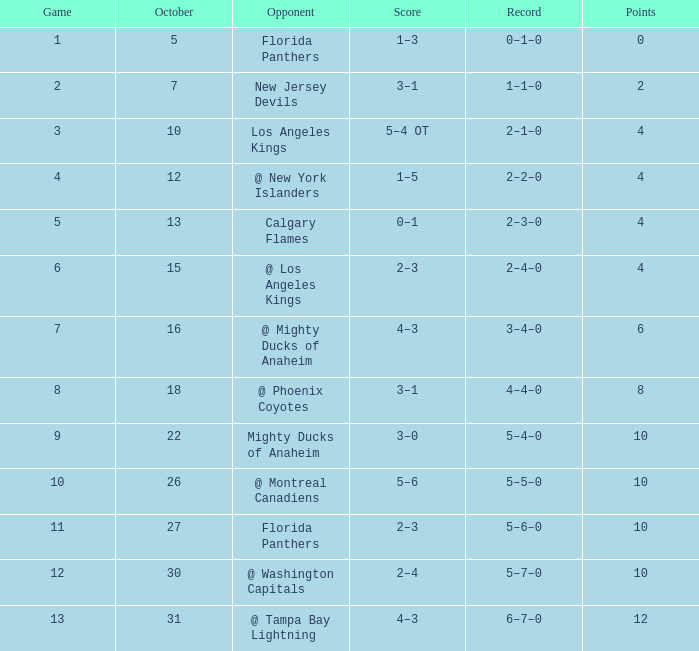What squad possesses a total of 11? 5–6–0. 